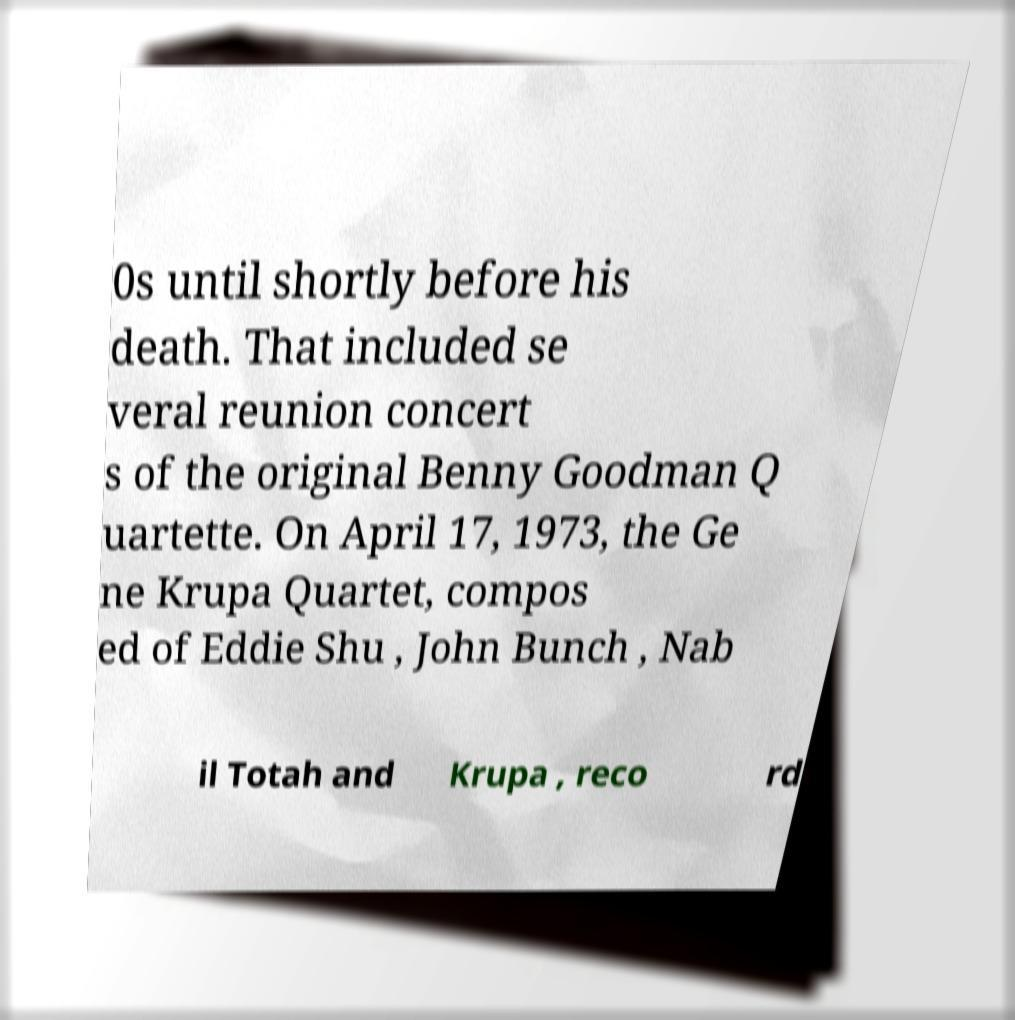Can you read and provide the text displayed in the image?This photo seems to have some interesting text. Can you extract and type it out for me? 0s until shortly before his death. That included se veral reunion concert s of the original Benny Goodman Q uartette. On April 17, 1973, the Ge ne Krupa Quartet, compos ed of Eddie Shu , John Bunch , Nab il Totah and Krupa , reco rd 